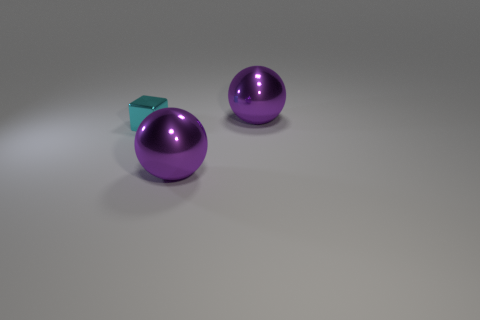How many metallic objects are cyan balls or large things?
Provide a succinct answer. 2. The ball in front of the big purple thing that is to the right of the large purple shiny ball in front of the tiny cyan thing is what color?
Ensure brevity in your answer.  Purple. How many big objects are either purple matte blocks or purple things?
Keep it short and to the point. 2. How many other things are the same color as the tiny thing?
Provide a succinct answer. 0. How many cyan objects are metal objects or shiny cubes?
Provide a short and direct response. 1. Is the number of shiny balls in front of the cyan shiny block the same as the number of big rubber spheres?
Keep it short and to the point. No. Is there any other thing that has the same size as the cyan shiny cube?
Provide a short and direct response. No. How many purple things are the same shape as the small cyan metal object?
Provide a succinct answer. 0. How many tiny blue rubber cylinders are there?
Your answer should be compact. 0. Is there another cube that has the same material as the cube?
Offer a terse response. No. 